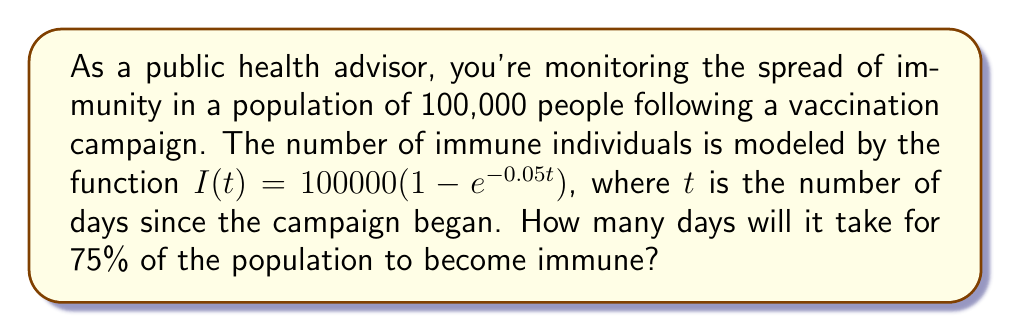Solve this math problem. To solve this problem, we need to follow these steps:

1) We want to find $t$ when $I(t)$ equals 75% of the population.
   75% of 100,000 is 75,000.

2) Set up the equation:
   $75000 = 100000(1 - e^{-0.05t})$

3) Divide both sides by 100000:
   $0.75 = 1 - e^{-0.05t}$

4) Subtract both sides from 1:
   $0.25 = e^{-0.05t}$

5) Take the natural log of both sides:
   $\ln(0.25) = -0.05t$

6) Solve for $t$:
   $t = \frac{\ln(0.25)}{-0.05}$

7) Calculate:
   $t = \frac{\ln(0.25)}{-0.05} \approx 27.73$ days

8) Since we're dealing with whole days, we round up to the next day.
Answer: It will take 28 days for 75% of the population to become immune. 